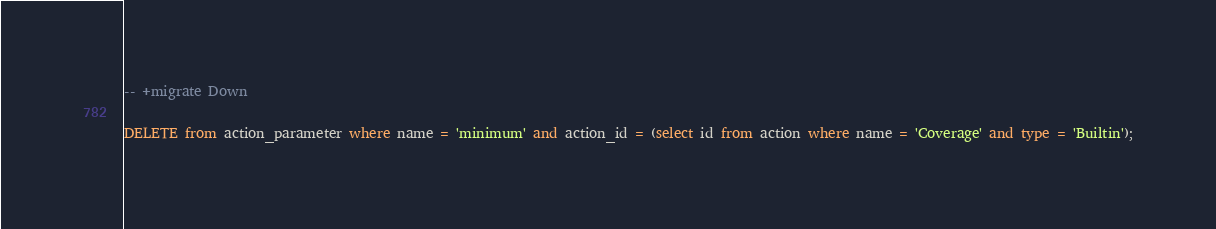<code> <loc_0><loc_0><loc_500><loc_500><_SQL_>
-- +migrate Down

DELETE from action_parameter where name = 'minimum' and action_id = (select id from action where name = 'Coverage' and type = 'Builtin');
</code> 